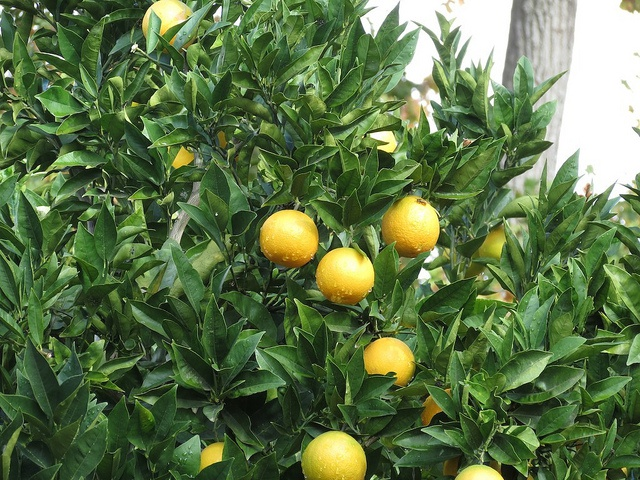Describe the objects in this image and their specific colors. I can see orange in darkgreen, gold, orange, and khaki tones, orange in darkgreen, khaki, orange, and gold tones, orange in darkgreen, khaki, olive, and gold tones, orange in darkgreen, gold, khaki, and orange tones, and orange in darkgreen, khaki, lightgreen, and lightyellow tones in this image. 